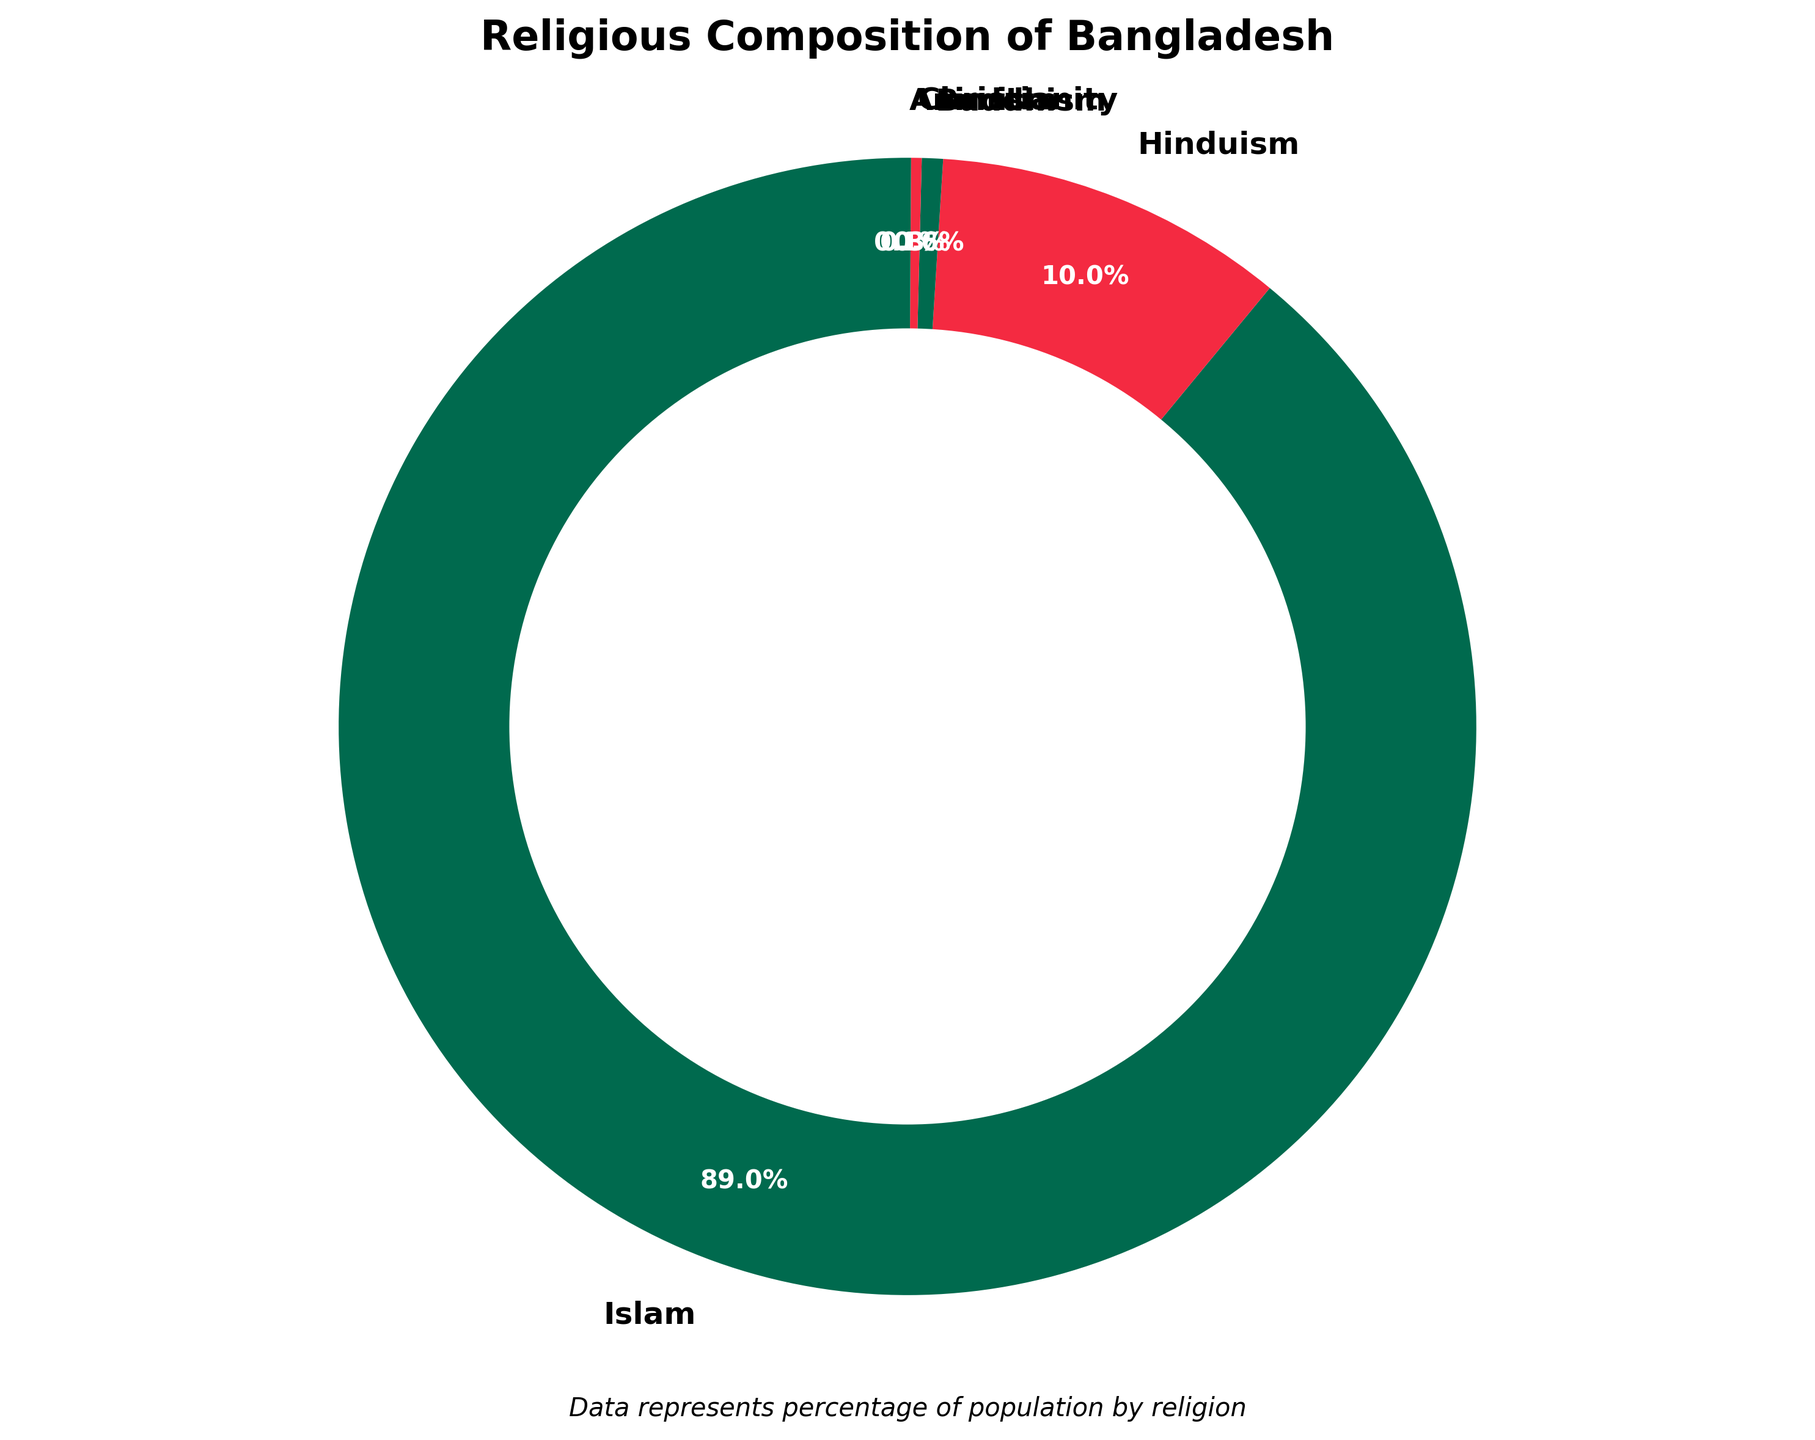What is the majority religion in Bangladesh according to the chart? By looking at the largest segment in the pie chart, it is labeled as "Islam" which covers the largest portion of the circle.
Answer: Islam How much larger is the Muslim population compared to the Hindu population? The figure shows that the Muslim population is 89.1%, and the Hindu population is 10.0%. Subtracting the two percentages: 89.1% - 10.0% = 79.1%.
Answer: 79.1% If you sum the populations of Buddhism, Christianity, and Animism, what percentage of the Bangladeshi population do they make up? The percentages are Buddhism 0.6%, Christianity 0.3%, and Animism 0.1%. Adding them together: 0.6% + 0.3% + 0.1% = 1.0%.
Answer: 1.0% Among the religious groups listed, which two have the smallest populations, and what is their combined percentage? The two smallest segments in the pie chart are Animism (0.1%) and Christianity (0.3%). Adding the two: 0.1% + 0.3% = 0.4%.
Answer: Animism and Christianity, 0.4% Is the proportion of the Hindu population greater than the combined proportions of Buddhists, Christians, and Animists? The Hindu population is 10.0%. The combined total of Buddhism, Christianity, and Animism is 1.0%. Comparing 10.0% with 1.0%, the Hindu population is indeed greater.
Answer: Yes Which segment uses the red color in the chart? By inspecting the visual attributes of the pie chart, the segments labeled Hinduism and Christianity use the red color.
Answer: Hinduism and Christianity What is the approximate ratio of the Muslim population to the total non-Muslim population in Bangladesh? The Muslim population is 89.1%. The non-Muslim populations (adding all other segments) total 10.9%. The ratio is 89.1:10.9. Simplifying this, it is approximately 8.2:1.
Answer: 8.2:1 